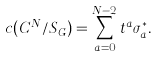<formula> <loc_0><loc_0><loc_500><loc_500>c ( { C } ^ { N } / S _ { G } ) = \sum _ { a = 0 } ^ { N - 2 } t ^ { a } \sigma _ { a } ^ { * } .</formula> 